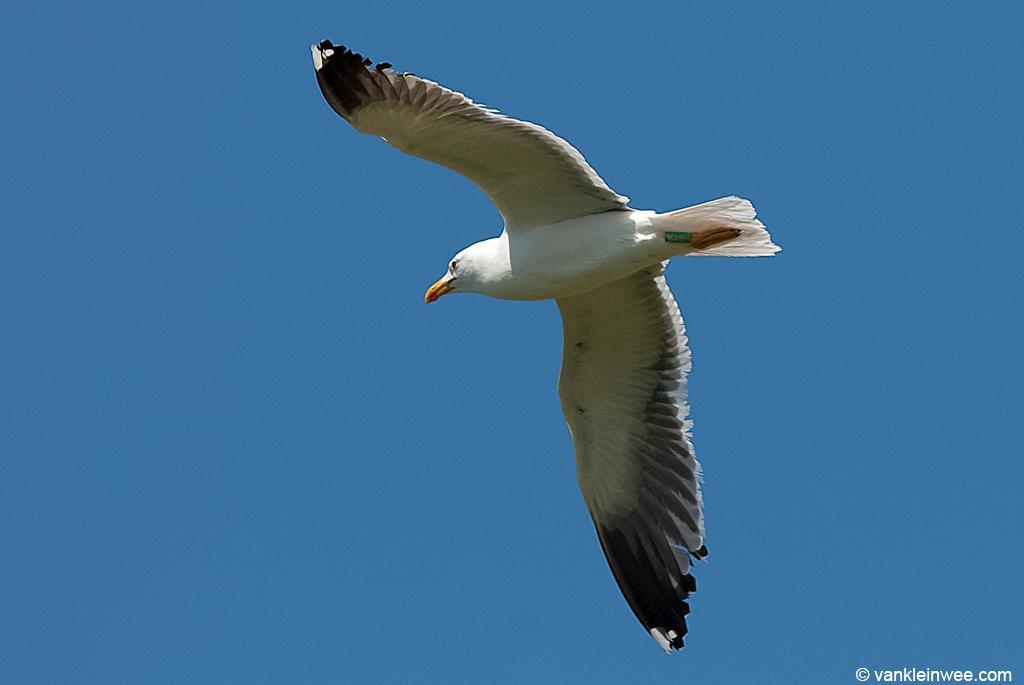Could you give a brief overview of what you see in this image? In the picture I can see a white color bird is flying in the air. In the background I can see the sky. On the bottom right of the image I can see a watermark. 